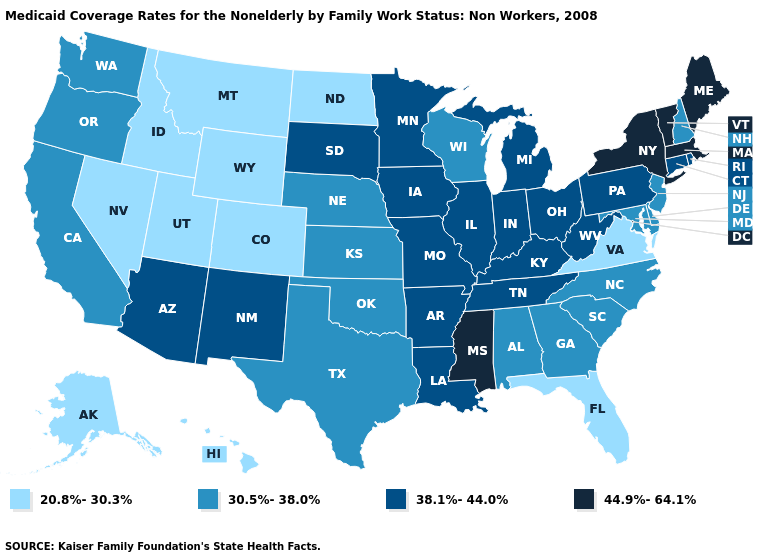What is the value of North Carolina?
Be succinct. 30.5%-38.0%. What is the value of Iowa?
Write a very short answer. 38.1%-44.0%. What is the lowest value in states that border Rhode Island?
Quick response, please. 38.1%-44.0%. What is the value of California?
Be succinct. 30.5%-38.0%. What is the highest value in states that border Kentucky?
Quick response, please. 38.1%-44.0%. Name the states that have a value in the range 44.9%-64.1%?
Concise answer only. Maine, Massachusetts, Mississippi, New York, Vermont. What is the value of Montana?
Concise answer only. 20.8%-30.3%. Name the states that have a value in the range 38.1%-44.0%?
Be succinct. Arizona, Arkansas, Connecticut, Illinois, Indiana, Iowa, Kentucky, Louisiana, Michigan, Minnesota, Missouri, New Mexico, Ohio, Pennsylvania, Rhode Island, South Dakota, Tennessee, West Virginia. Among the states that border Missouri , does Nebraska have the lowest value?
Answer briefly. Yes. What is the highest value in the USA?
Give a very brief answer. 44.9%-64.1%. Among the states that border New York , does Massachusetts have the highest value?
Write a very short answer. Yes. What is the value of New Mexico?
Answer briefly. 38.1%-44.0%. What is the highest value in states that border South Carolina?
Short answer required. 30.5%-38.0%. Name the states that have a value in the range 30.5%-38.0%?
Be succinct. Alabama, California, Delaware, Georgia, Kansas, Maryland, Nebraska, New Hampshire, New Jersey, North Carolina, Oklahoma, Oregon, South Carolina, Texas, Washington, Wisconsin. What is the value of Nebraska?
Answer briefly. 30.5%-38.0%. 